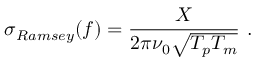Convert formula to latex. <formula><loc_0><loc_0><loc_500><loc_500>\sigma _ { R a m s e y } ( f ) = \frac { X } { 2 \pi \nu _ { 0 } \sqrt { T _ { p } T _ { m } } } \ .</formula> 